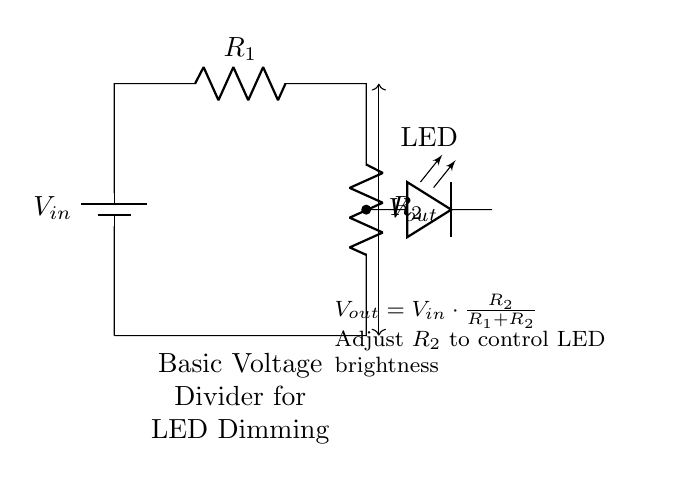What is the input voltage in the circuit? The input voltage is indicated as \( V_{in} \) at the battery component at the top of the circuit. This value is not specified numerically in the diagram, so it remains a variable.
Answer: V input What are the resistor values represented in the circuit? The circuit has two resistors, \( R_1 \) and \( R_2 \), but specific numerical values for these components are not provided in the diagram. The labels alone signify their roles in the voltage division without giving actual resistance values.
Answer: R1 and R2 What does \( V_{out} \) represent? \( V_{out} \) is the output voltage and is defined on the diagram with an arrow between the resistors, indicating the point at which voltage is measured across \( R_2 \). It's derived from the input voltage based on the voltage divider formula shown below the circuit.
Answer: Output voltage How can the brightness of the LED be controlled? The brightness of the LED can be controlled by adjusting the resistance of \( R_2 \). Increasing \( R_2 \) increases \( V_{out} \), which in turn increases the brightness of the LED, as more voltage results in more current through the LED.
Answer: Adjusting R2 What is the relationship between \( V_{out} \), \( V_{in} \), \( R_1 \), and \( R_2 \)? The relationship is defined by the equation \( V_{out} = V_{in} \cdot \frac{R_2}{R_1 + R_2} \). This equation shows how the output voltage is a fraction of the input voltage based on the resistances. It explains how \( V_{out} \) varies with \( R_1 \) and \( R_2 \).
Answer: Voltage divider equation What type of circuit is this an example of? This circuit is an example of a voltage divider circuit. It utilizes two resistors to divide the input voltage to lower levels, enabling control over the voltage supplied to the LED for dimming purposes.
Answer: Voltage divider circuit 